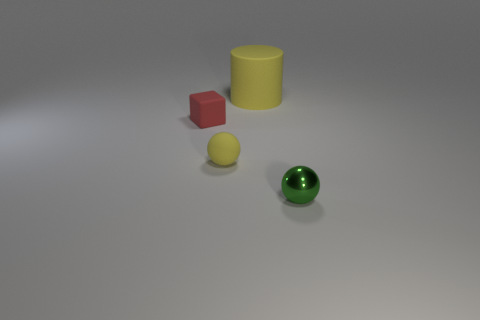Is there anything else that has the same material as the tiny green thing?
Your answer should be very brief. No. How many metal things are either brown objects or cylinders?
Provide a short and direct response. 0. What is the shape of the large object that is the same material as the red cube?
Your answer should be compact. Cylinder. What number of other tiny red things are the same shape as the metallic object?
Provide a succinct answer. 0. Does the yellow rubber thing that is in front of the tiny red matte thing have the same shape as the metal thing right of the small rubber cube?
Your answer should be compact. Yes. What number of things are either big brown matte spheres or yellow objects that are in front of the small red rubber object?
Ensure brevity in your answer.  1. There is another rubber thing that is the same color as the large thing; what is its shape?
Offer a terse response. Sphere. What number of yellow rubber things have the same size as the green shiny sphere?
Keep it short and to the point. 1. How many red things are either large cylinders or small objects?
Keep it short and to the point. 1. What is the shape of the tiny rubber thing that is to the left of the sphere that is left of the metal thing?
Provide a short and direct response. Cube. 